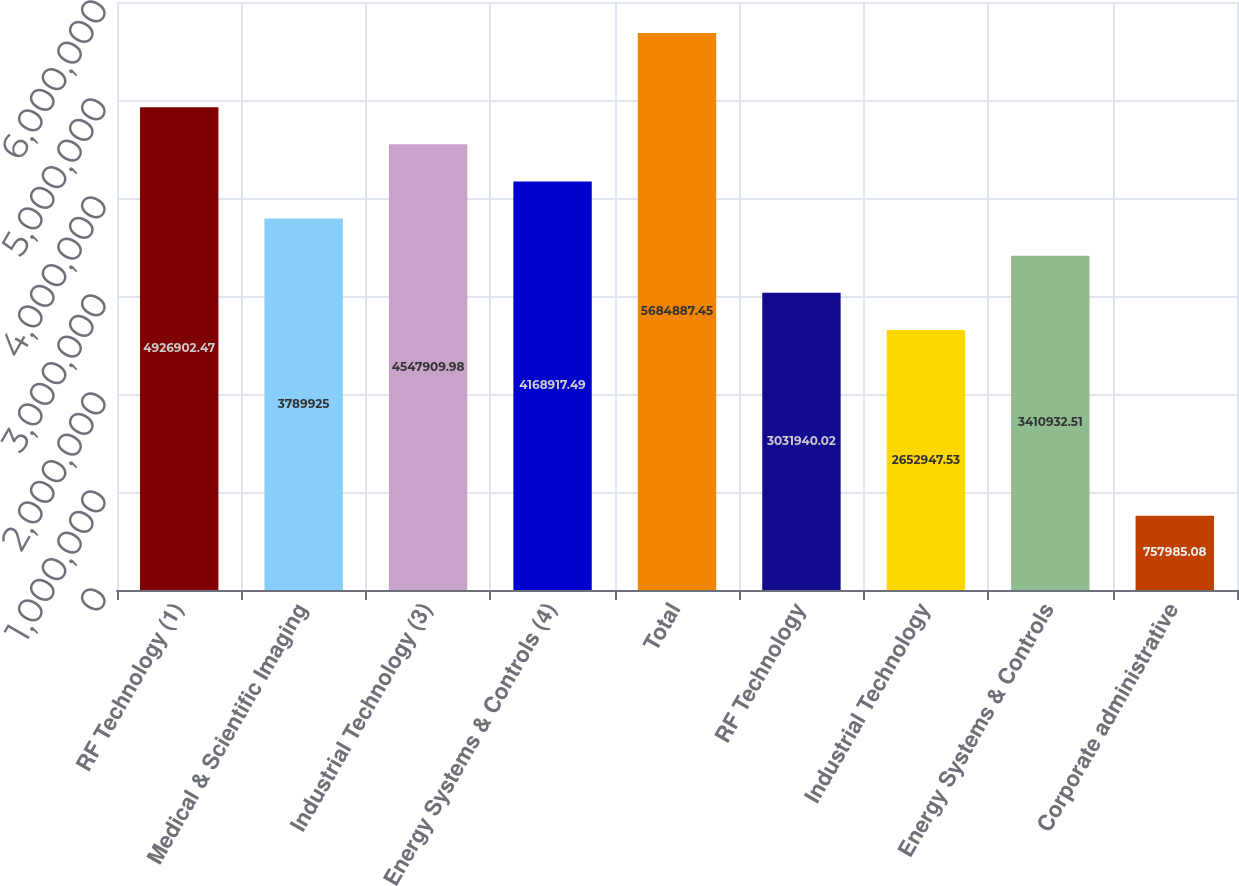Convert chart. <chart><loc_0><loc_0><loc_500><loc_500><bar_chart><fcel>RF Technology (1)<fcel>Medical & Scientific Imaging<fcel>Industrial Technology (3)<fcel>Energy Systems & Controls (4)<fcel>Total<fcel>RF Technology<fcel>Industrial Technology<fcel>Energy Systems & Controls<fcel>Corporate administrative<nl><fcel>4.9269e+06<fcel>3.78992e+06<fcel>4.54791e+06<fcel>4.16892e+06<fcel>5.68489e+06<fcel>3.03194e+06<fcel>2.65295e+06<fcel>3.41093e+06<fcel>757985<nl></chart> 